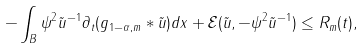Convert formula to latex. <formula><loc_0><loc_0><loc_500><loc_500>- \int _ { B } \psi ^ { 2 } \tilde { u } ^ { - 1 } \partial _ { t } ( g _ { 1 - \alpha , m } * \tilde { u } ) d x + \mathcal { E } ( \tilde { u } , - \psi ^ { 2 } \tilde { u } ^ { - 1 } ) \leq R _ { m } ( t ) ,</formula> 